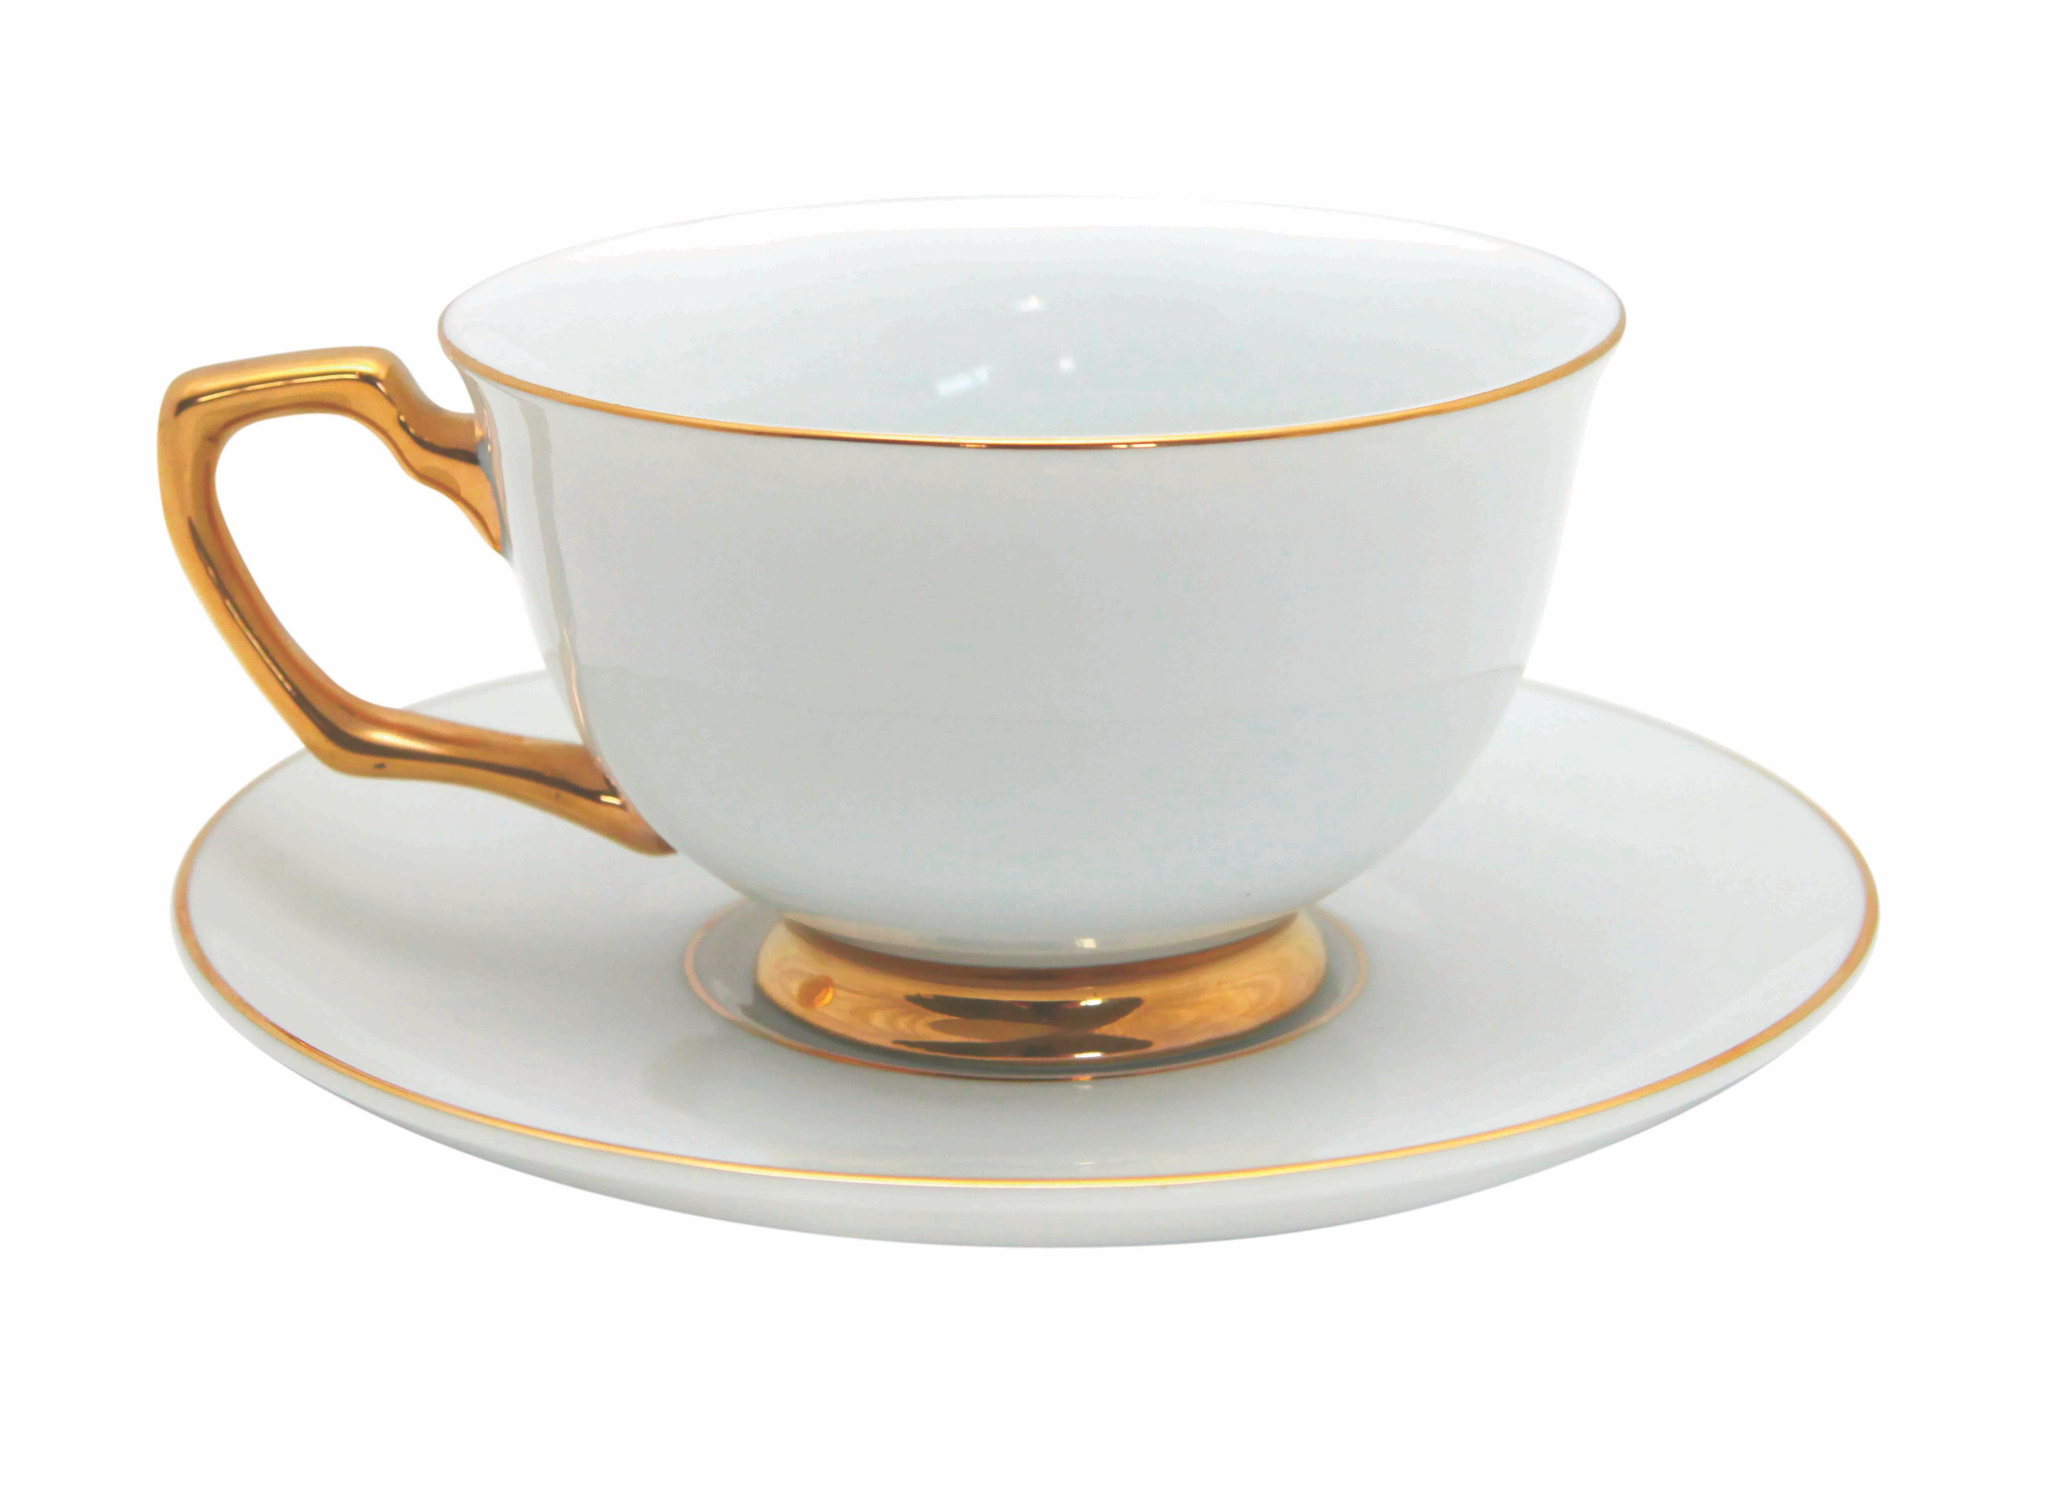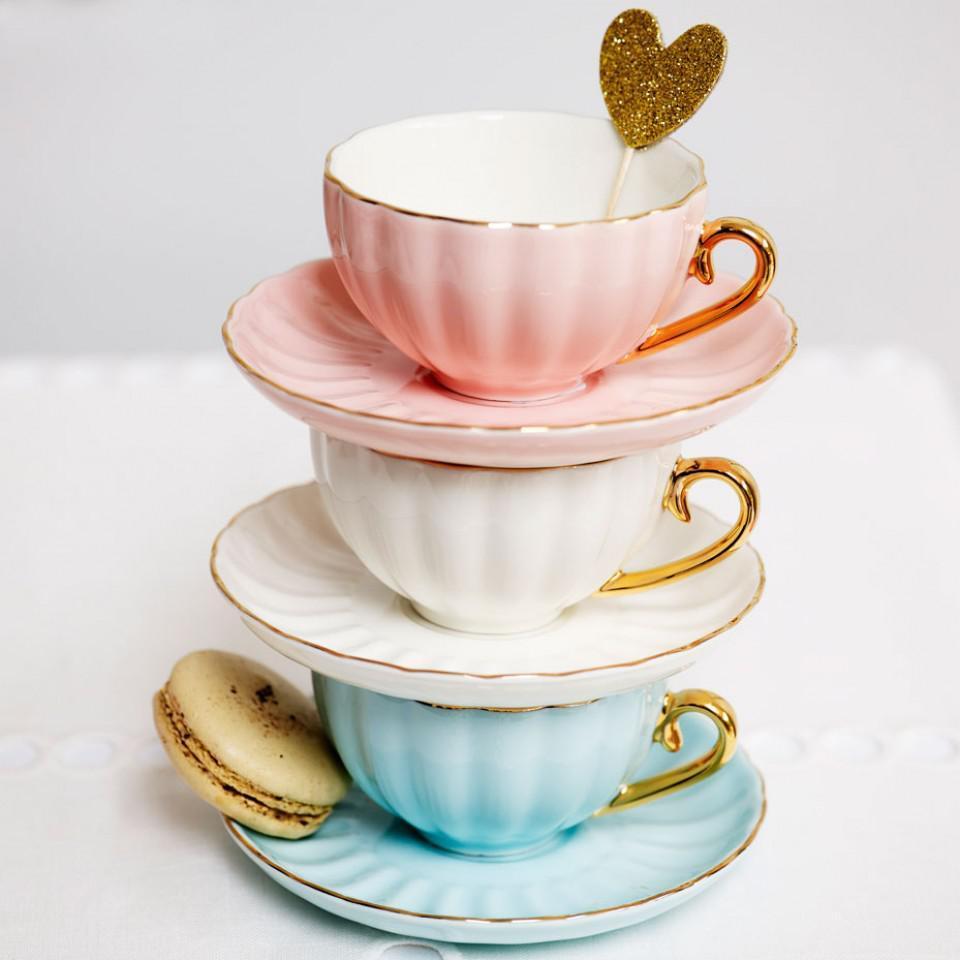The first image is the image on the left, the second image is the image on the right. For the images displayed, is the sentence "An image shows a trio of gold-trimmed cup and saucer sets, including one that is robin's egg blue." factually correct? Answer yes or no. Yes. The first image is the image on the left, the second image is the image on the right. For the images shown, is this caption "Exactly four different cups with matching saucers are shown, three in one image and one in a second image." true? Answer yes or no. Yes. 